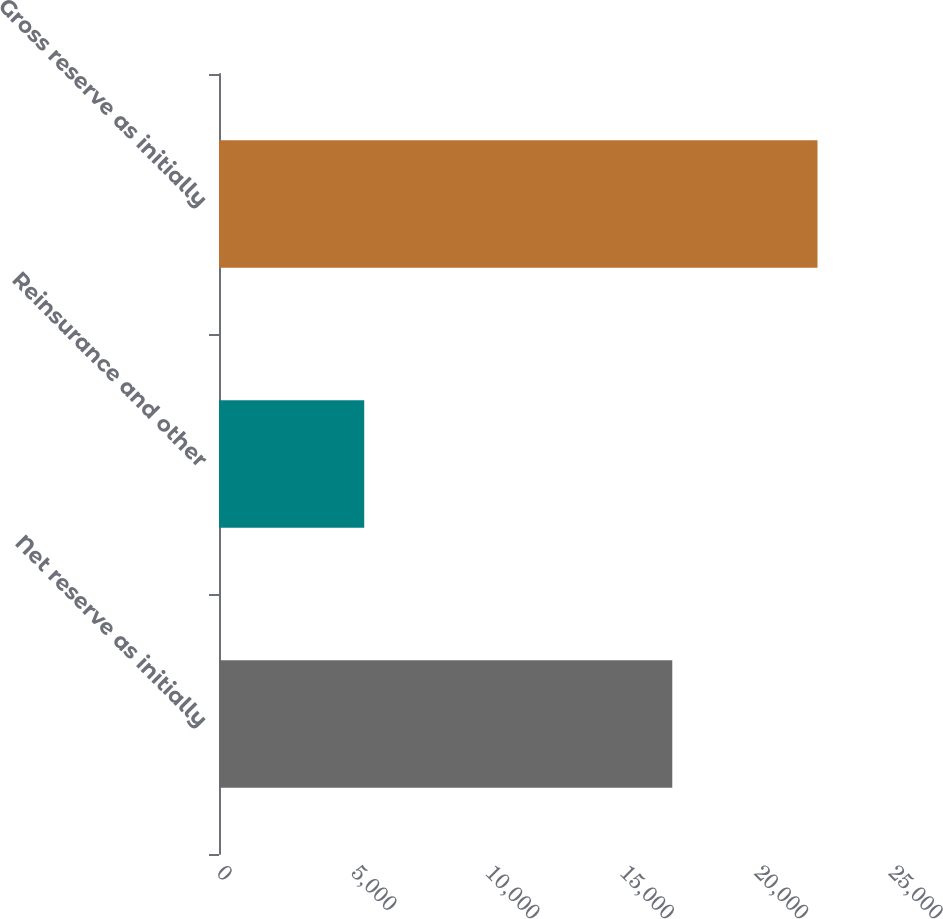<chart> <loc_0><loc_0><loc_500><loc_500><bar_chart><fcel>Net reserve as initially<fcel>Reinsurance and other<fcel>Gross reserve as initially<nl><fcel>16863<fcel>5403<fcel>22266<nl></chart> 